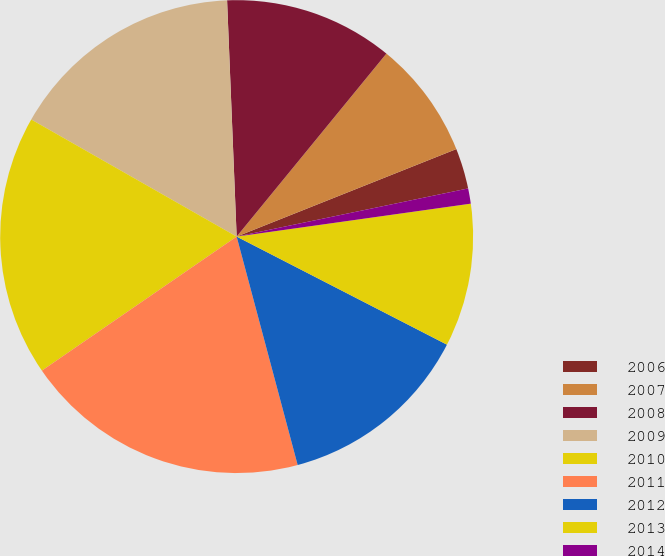Convert chart. <chart><loc_0><loc_0><loc_500><loc_500><pie_chart><fcel>2006<fcel>2007<fcel>2008<fcel>2009<fcel>2010<fcel>2011<fcel>2012<fcel>2013<fcel>2014<nl><fcel>2.77%<fcel>8.05%<fcel>11.56%<fcel>16.11%<fcel>17.84%<fcel>19.56%<fcel>13.29%<fcel>9.78%<fcel>1.04%<nl></chart> 